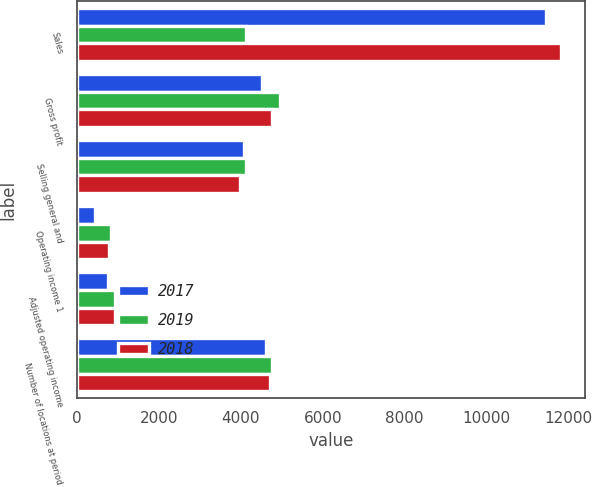Convert chart. <chart><loc_0><loc_0><loc_500><loc_500><stacked_bar_chart><ecel><fcel>Sales<fcel>Gross profit<fcel>Selling general and<fcel>Operating income 1<fcel>Adjusted operating income<fcel>Number of locations at period<nl><fcel>2017<fcel>11462<fcel>4522<fcel>4084<fcel>438<fcel>747<fcel>4605<nl><fcel>2019<fcel>4134<fcel>4958<fcel>4134<fcel>824<fcel>929<fcel>4767<nl><fcel>2018<fcel>11813<fcel>4753<fcel>3982<fcel>771<fcel>939<fcel>4722<nl></chart> 